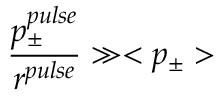Convert formula to latex. <formula><loc_0><loc_0><loc_500><loc_500>\frac { p _ { \pm } ^ { p u l s e } } { r ^ { p u l s e } } \gg < p _ { \pm } ></formula> 